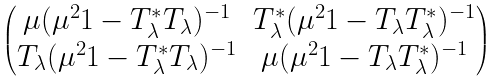<formula> <loc_0><loc_0><loc_500><loc_500>\begin{pmatrix} \mu ( \mu ^ { 2 } 1 - T ^ { * } _ { \lambda } T _ { \lambda } ) ^ { - 1 } & T ^ { * } _ { \lambda } ( \mu ^ { 2 } 1 - T _ { \lambda } T ^ { * } _ { \lambda } ) ^ { - 1 } \\ T _ { \lambda } ( \mu ^ { 2 } 1 - T ^ { * } _ { \lambda } T _ { \lambda } ) ^ { - 1 } & \mu ( \mu ^ { 2 } 1 - T _ { \lambda } T ^ { * } _ { \lambda } ) ^ { - 1 } \end{pmatrix}</formula> 